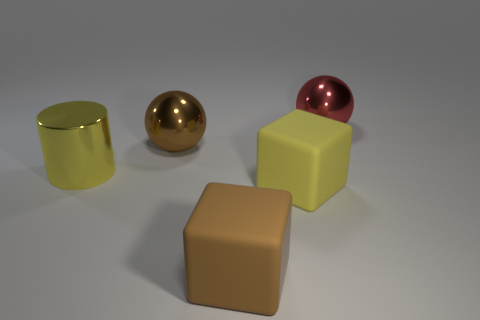Are there any other things that are the same shape as the yellow shiny object?
Provide a short and direct response. No. Is there a matte object that has the same color as the shiny cylinder?
Offer a very short reply. Yes. Are the red ball and the large yellow cylinder made of the same material?
Ensure brevity in your answer.  Yes. There is a large brown ball; what number of large cubes are to the left of it?
Keep it short and to the point. 0. What material is the big object that is both right of the brown matte thing and in front of the big red sphere?
Your response must be concise. Rubber. What number of purple rubber things are the same size as the red thing?
Your response must be concise. 0. There is a metal object that is right of the large sphere in front of the red sphere; what is its color?
Make the answer very short. Red. Are any gray matte cubes visible?
Your answer should be compact. No. Does the large yellow matte object have the same shape as the big brown metallic object?
Offer a terse response. No. There is a rubber object that is the same color as the big cylinder; what is its size?
Give a very brief answer. Large. 